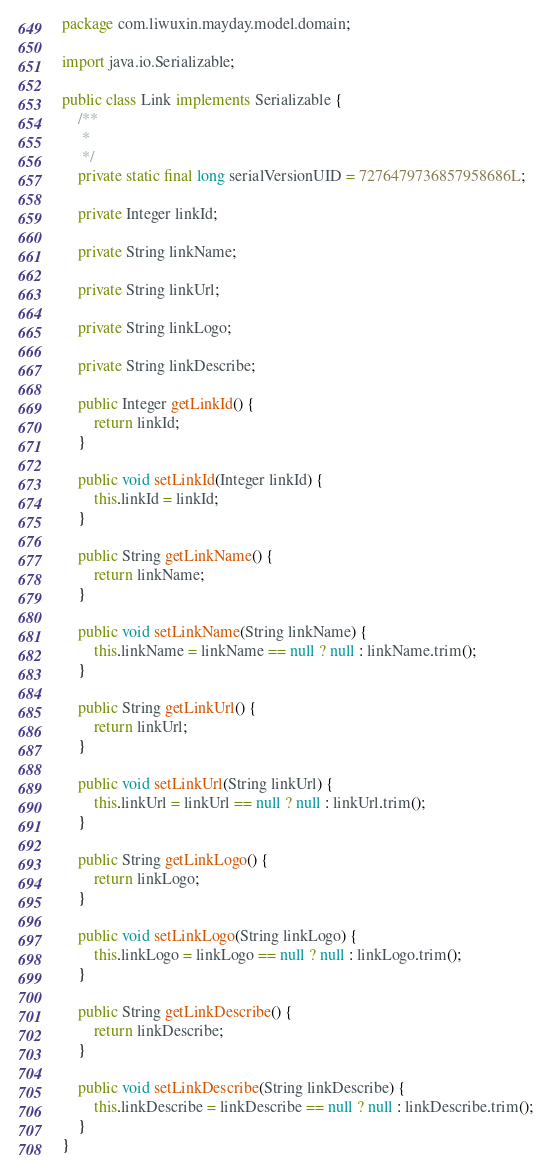<code> <loc_0><loc_0><loc_500><loc_500><_Java_>package com.liwuxin.mayday.model.domain;

import java.io.Serializable;

public class Link implements Serializable {
	/**
	 * 
	 */
	private static final long serialVersionUID = 7276479736857958686L;

	private Integer linkId;

	private String linkName;

	private String linkUrl;

	private String linkLogo;

	private String linkDescribe;

	public Integer getLinkId() {
		return linkId;
	}

	public void setLinkId(Integer linkId) {
		this.linkId = linkId;
	}

	public String getLinkName() {
		return linkName;
	}

	public void setLinkName(String linkName) {
		this.linkName = linkName == null ? null : linkName.trim();
	}

	public String getLinkUrl() {
		return linkUrl;
	}

	public void setLinkUrl(String linkUrl) {
		this.linkUrl = linkUrl == null ? null : linkUrl.trim();
	}

	public String getLinkLogo() {
		return linkLogo;
	}

	public void setLinkLogo(String linkLogo) {
		this.linkLogo = linkLogo == null ? null : linkLogo.trim();
	}

	public String getLinkDescribe() {
		return linkDescribe;
	}

	public void setLinkDescribe(String linkDescribe) {
		this.linkDescribe = linkDescribe == null ? null : linkDescribe.trim();
	}
}</code> 